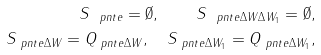Convert formula to latex. <formula><loc_0><loc_0><loc_500><loc_500>S _ { \ p n t { e } } = \emptyset , \quad S _ { \ p n t { e } \Delta W \Delta W _ { 1 } } = \emptyset , \\ S _ { \ p n t { e } \Delta W } = Q _ { \ p n t { e } \Delta W } , \quad S _ { \ p n t { e } \Delta W _ { 1 } } = Q _ { \ p n t { e } \Delta W _ { 1 } } ,</formula> 